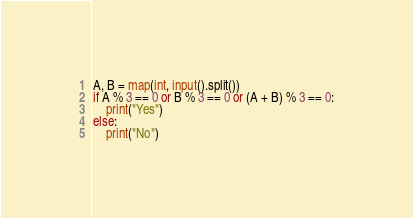Convert code to text. <code><loc_0><loc_0><loc_500><loc_500><_Python_>A, B = map(int, input().split())
if A % 3 == 0 or B % 3 == 0 or (A + B) % 3 == 0:
    print("Yes")
else:
    print("No")</code> 